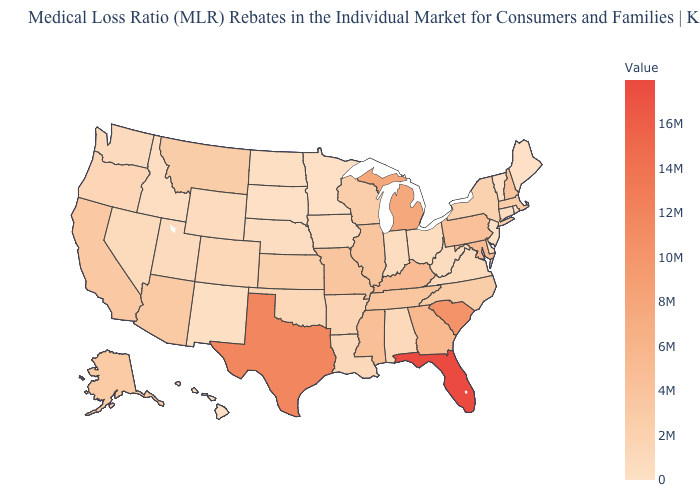Among the states that border Wisconsin , does Michigan have the lowest value?
Quick response, please. No. Does Maine have the lowest value in the USA?
Be succinct. Yes. Among the states that border Minnesota , which have the highest value?
Short answer required. Wisconsin. Which states have the lowest value in the MidWest?
Short answer required. Minnesota, South Dakota. Which states have the highest value in the USA?
Write a very short answer. Florida. Does Florida have the highest value in the USA?
Give a very brief answer. Yes. 